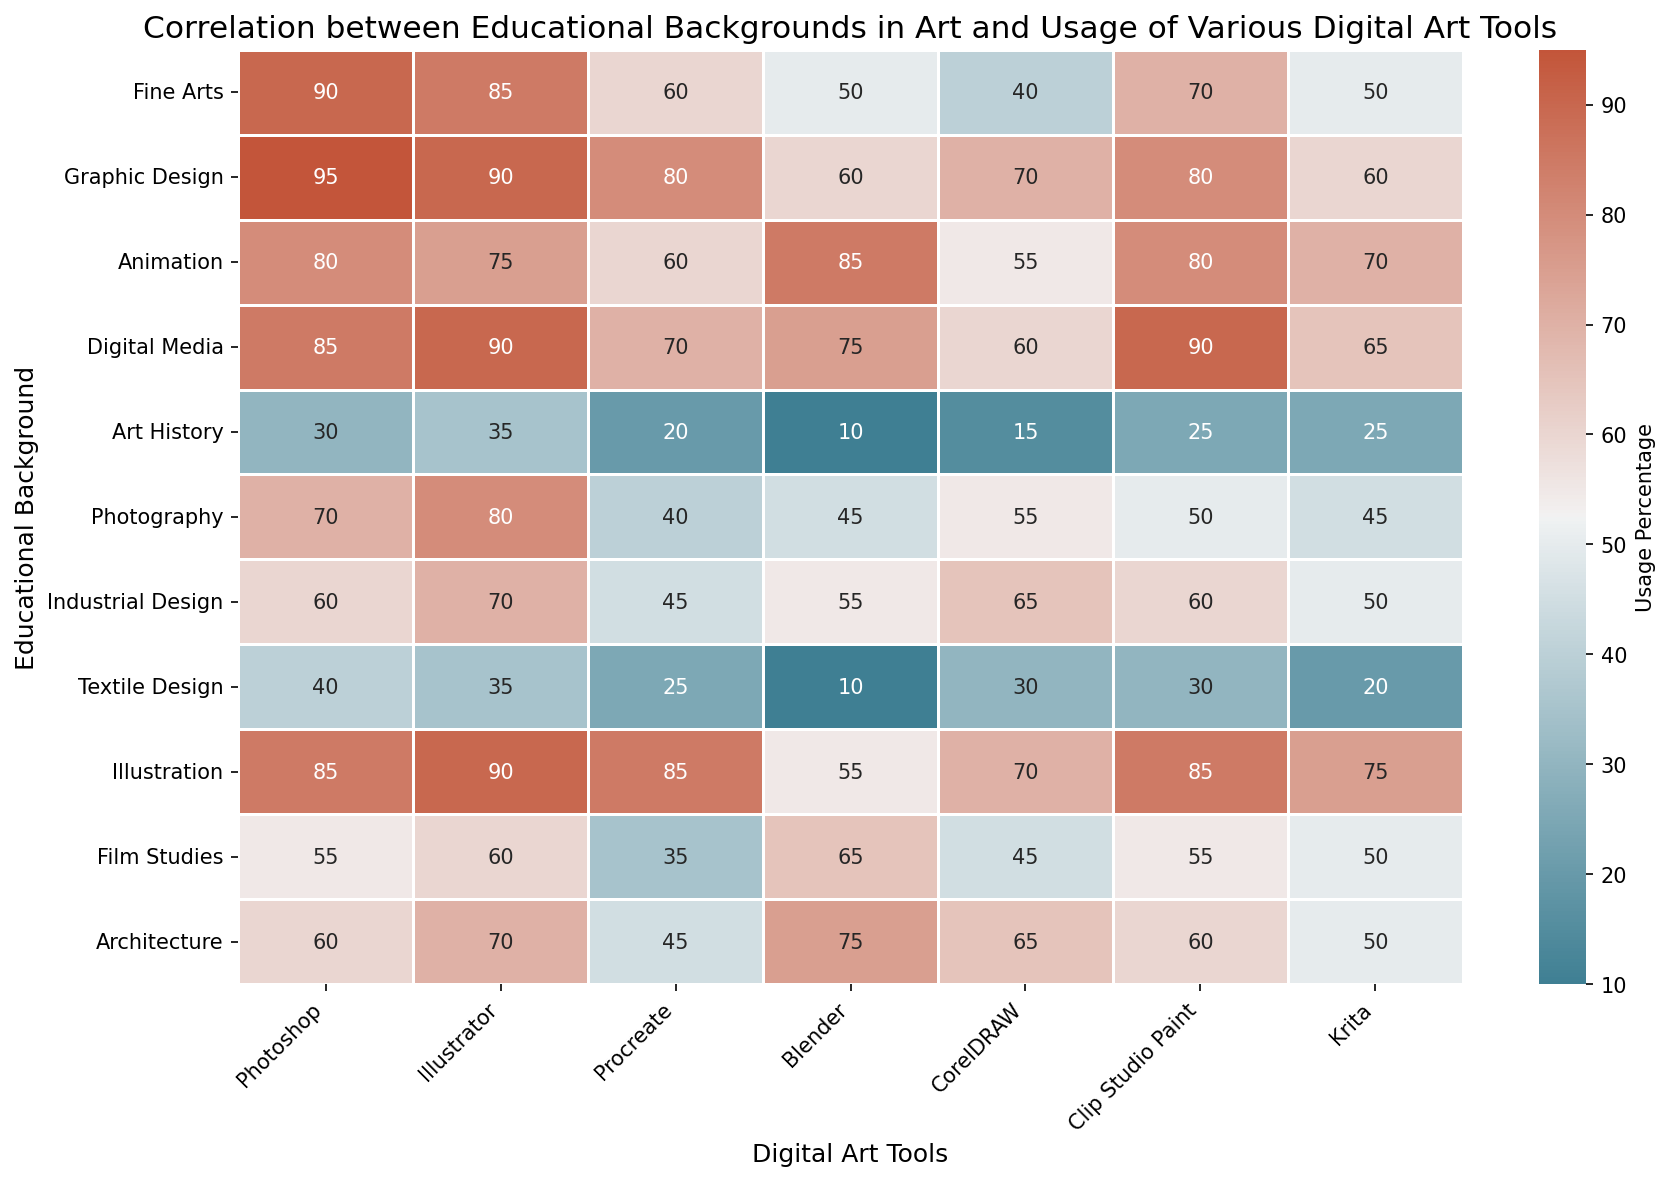What educational background has the highest usage of Procreate? First, locate the column for Procreate in the heatmap. Then, identify the educational background with the highest value in that column (which is 85). This corresponds to Illustration.
Answer: Illustration Which digital tool is least used by Art History students? Find the row for Art History. Look for the smallest value in that row, which is 10. This value corresponds to Blender.
Answer: Blender Between Graphic Design and Digital Media, which background has a higher average usage of all tools? Calculate the average usage for each background:
- Graphic Design: (95+90+80+60+70+80+60)/7 = 76.43
- Digital Media: (85+90+70+75+60+90+65)/7 = 76.43
Both have the same average.
Answer: Both have the same average Compare the usage of Photoshop between Fine Arts and Film Studies backgrounds. Who uses it more? Examine the values under the Photoshop column for Fine Arts (90) and Film Studies (55). Since 90 is greater than 55, Fine Arts has higher usage.
Answer: Fine Arts What is the most popular digital art tool among Animation students? Look at the row for Animation in the heatmap. The highest value in that row is 85, which corresponds to Blender.
Answer: Blender What digital art tool is used most consistently across all educational backgrounds? Calculate the range (max-min) for each column:
- Photoshop: max = 95, min = 30, range = 65
- Illustrator: max = 90, min = 35, range = 55
- Procreate: max = 85, min = 20, range = 65
- Blender: max = 85, min = 10, range = 75
- CorelDRAW: max = 70, min = 15, range = 55
- Clip Studio Paint: max = 90, min = 25, range = 65
- Krita: max = 75, min = 20, range = 55
The tools with the smallest range are Illustrator, CorelDRAW, and Krita.
Answer: Illustrator, CorelDRAW, and Krita Which educational background shows the highest variability in the usage of digital art tools? Calculate the standard deviation for each row:
- Fine Arts: Std Dev ≈ 18.38
- Graphic Design: Std Dev ≈ 12.49
- Animation: Std Dev ≈ 9.98
- Digital Media: Std Dev ≈ 10.25
- Art History: Std Dev ≈ 8.55
- Photography: Std Dev ≈ 15.33
- Industrial Design: Std Dev ≈ 9.67
- Textile Design: Std Dev ≈ 10.89
- Illustration: Std Dev ≈ 11.08
- Film Studies: Std Dev ≈ 10.07
- Architecture: Std Dev ≈ 11.59
Fine Arts has the highest standard deviation.
Answer: Fine Arts 